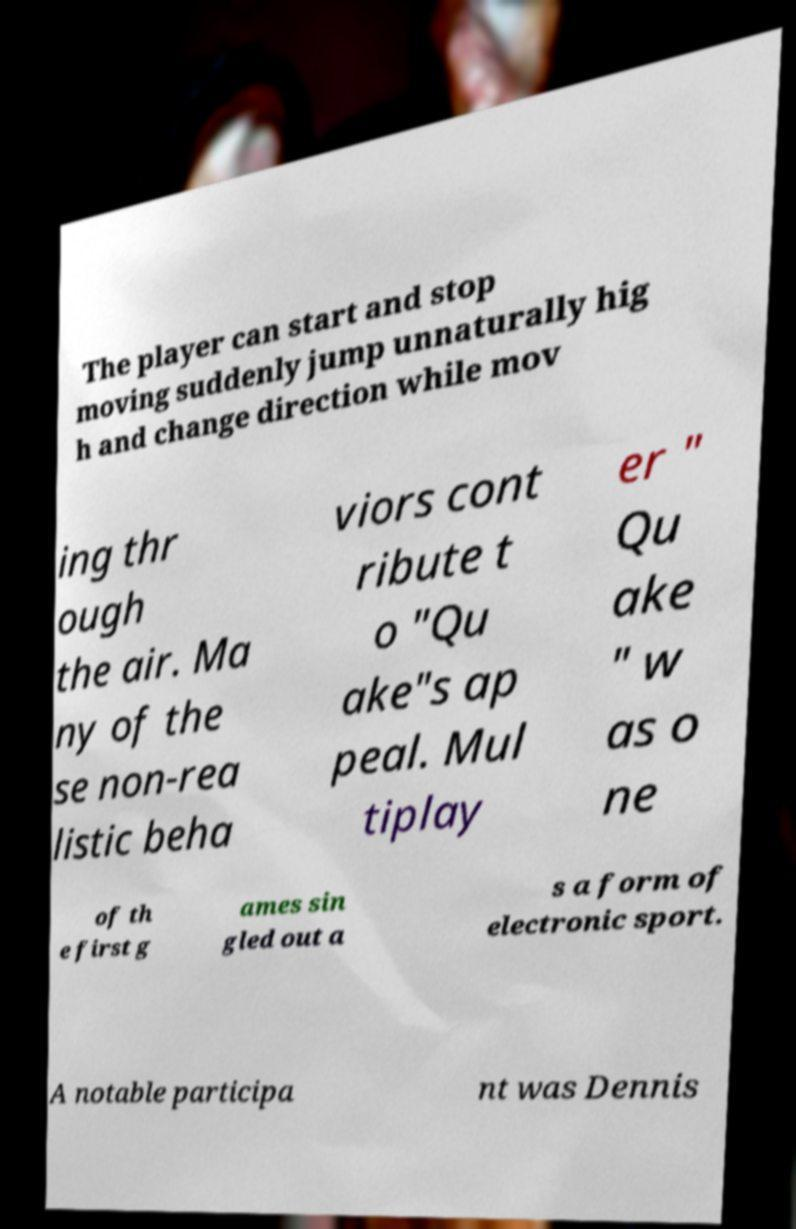Could you assist in decoding the text presented in this image and type it out clearly? The player can start and stop moving suddenly jump unnaturally hig h and change direction while mov ing thr ough the air. Ma ny of the se non-rea listic beha viors cont ribute t o "Qu ake"s ap peal. Mul tiplay er " Qu ake " w as o ne of th e first g ames sin gled out a s a form of electronic sport. A notable participa nt was Dennis 